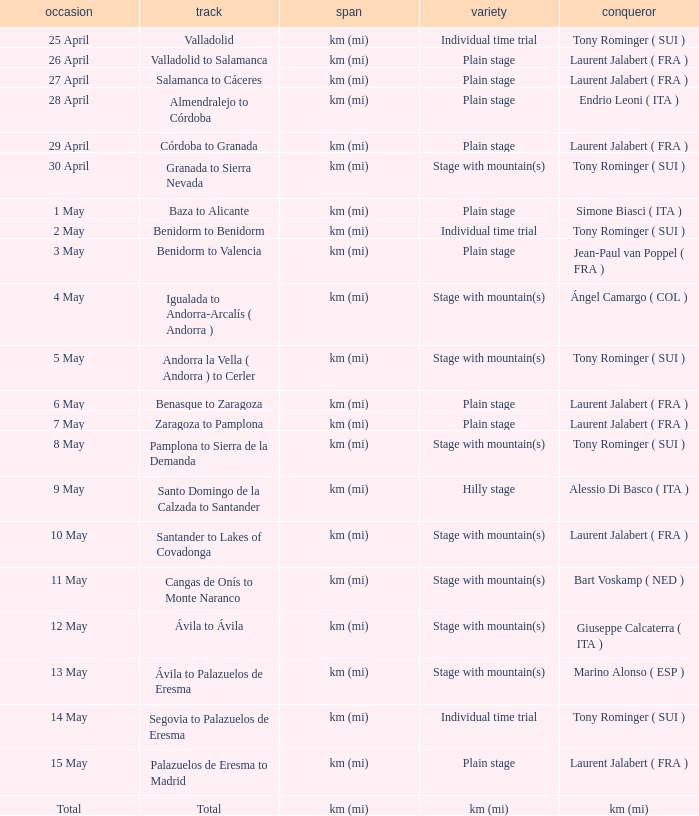What was the date with a winner of km (mi)? Total. 